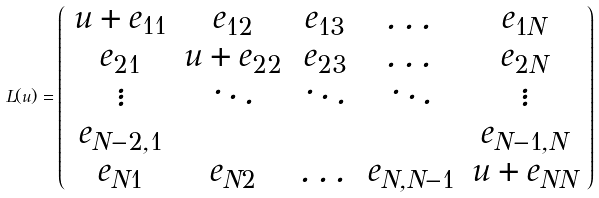<formula> <loc_0><loc_0><loc_500><loc_500>L ( u ) = \left ( \begin{array} { c c c c c } u + e _ { 1 1 } & e _ { 1 2 } & e _ { 1 3 } & \dots & e _ { 1 N } \\ e _ { 2 1 } & u + e _ { 2 2 } & e _ { 2 3 } & \dots & e _ { 2 N } \\ \vdots & \ddots & \ddots & \ddots & \vdots \\ e _ { N - 2 , 1 } & & & & e _ { N - 1 , N } \\ e _ { N 1 } & e _ { N 2 } & \dots & e _ { N , N - 1 } & u + e _ { N N } \end{array} \right )</formula> 